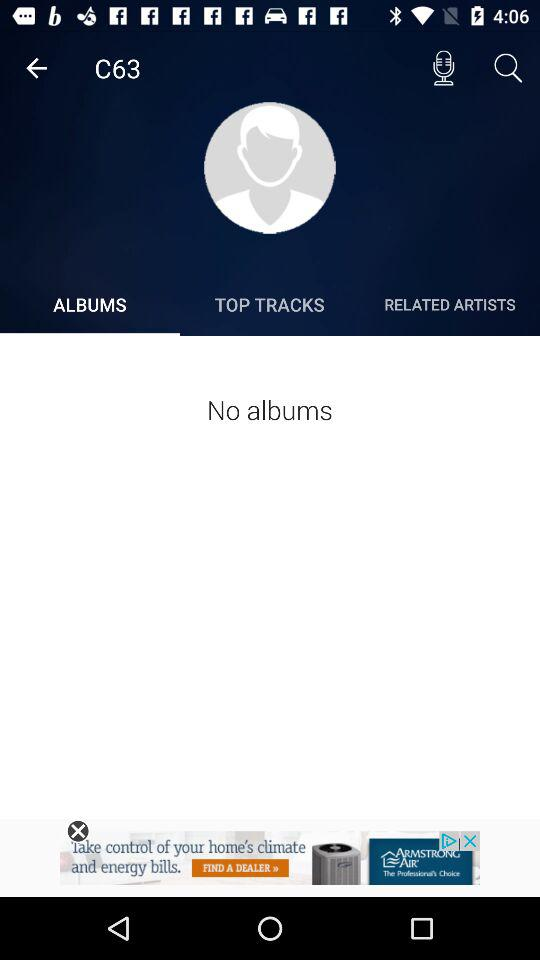Which tab is selected? The selected tab is "ALBUMS". 